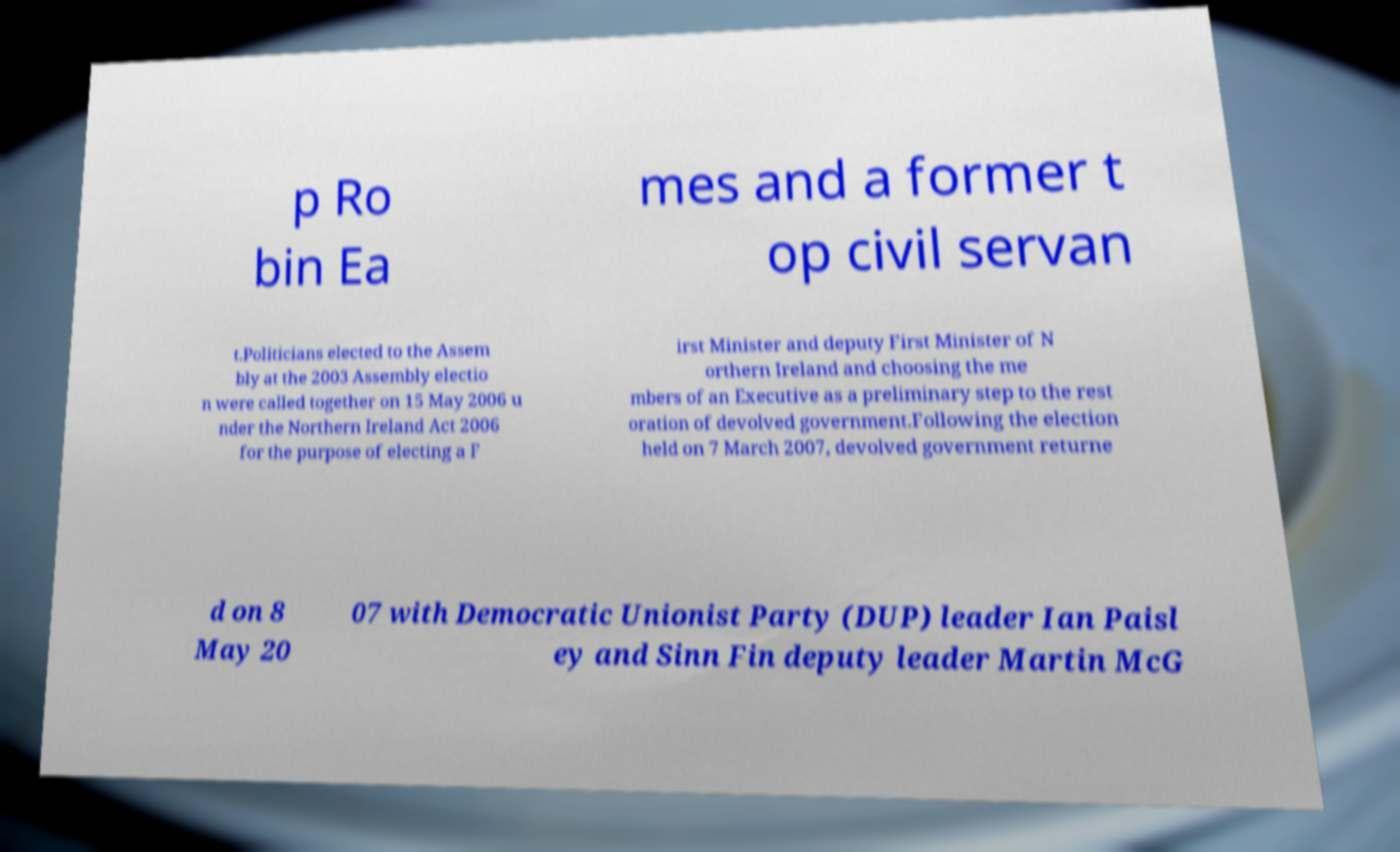Please identify and transcribe the text found in this image. p Ro bin Ea mes and a former t op civil servan t.Politicians elected to the Assem bly at the 2003 Assembly electio n were called together on 15 May 2006 u nder the Northern Ireland Act 2006 for the purpose of electing a F irst Minister and deputy First Minister of N orthern Ireland and choosing the me mbers of an Executive as a preliminary step to the rest oration of devolved government.Following the election held on 7 March 2007, devolved government returne d on 8 May 20 07 with Democratic Unionist Party (DUP) leader Ian Paisl ey and Sinn Fin deputy leader Martin McG 